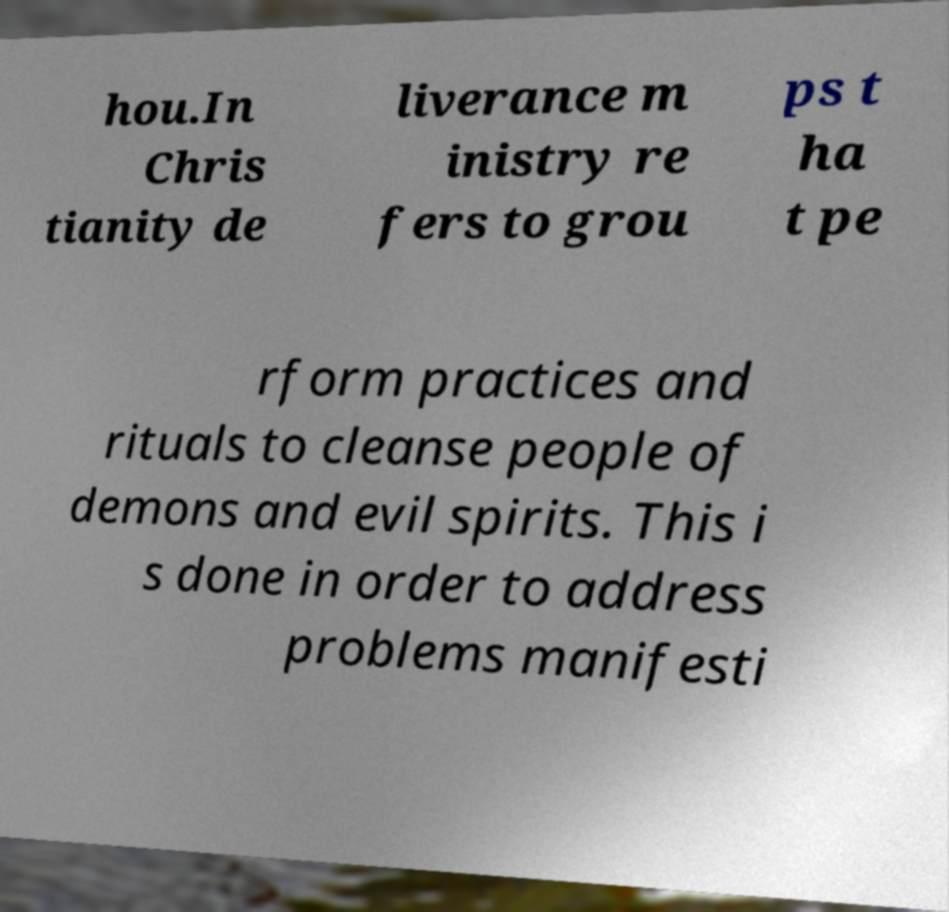Can you accurately transcribe the text from the provided image for me? hou.In Chris tianity de liverance m inistry re fers to grou ps t ha t pe rform practices and rituals to cleanse people of demons and evil spirits. This i s done in order to address problems manifesti 